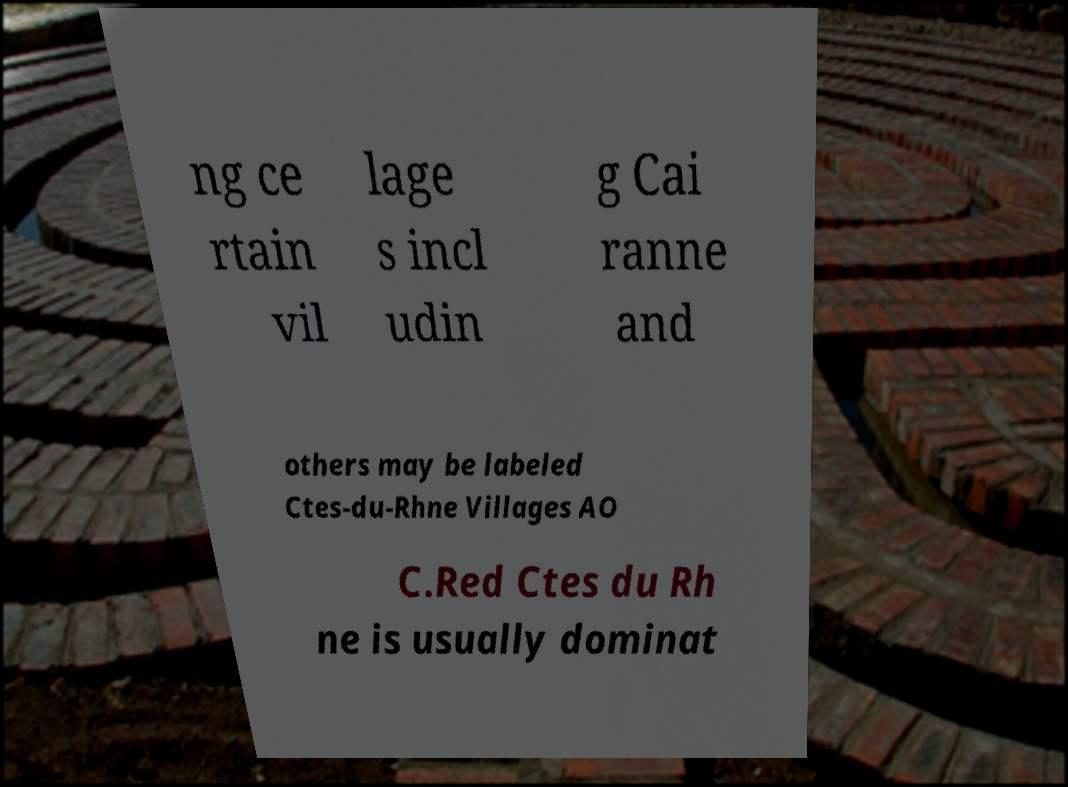I need the written content from this picture converted into text. Can you do that? ng ce rtain vil lage s incl udin g Cai ranne and others may be labeled Ctes-du-Rhne Villages AO C.Red Ctes du Rh ne is usually dominat 